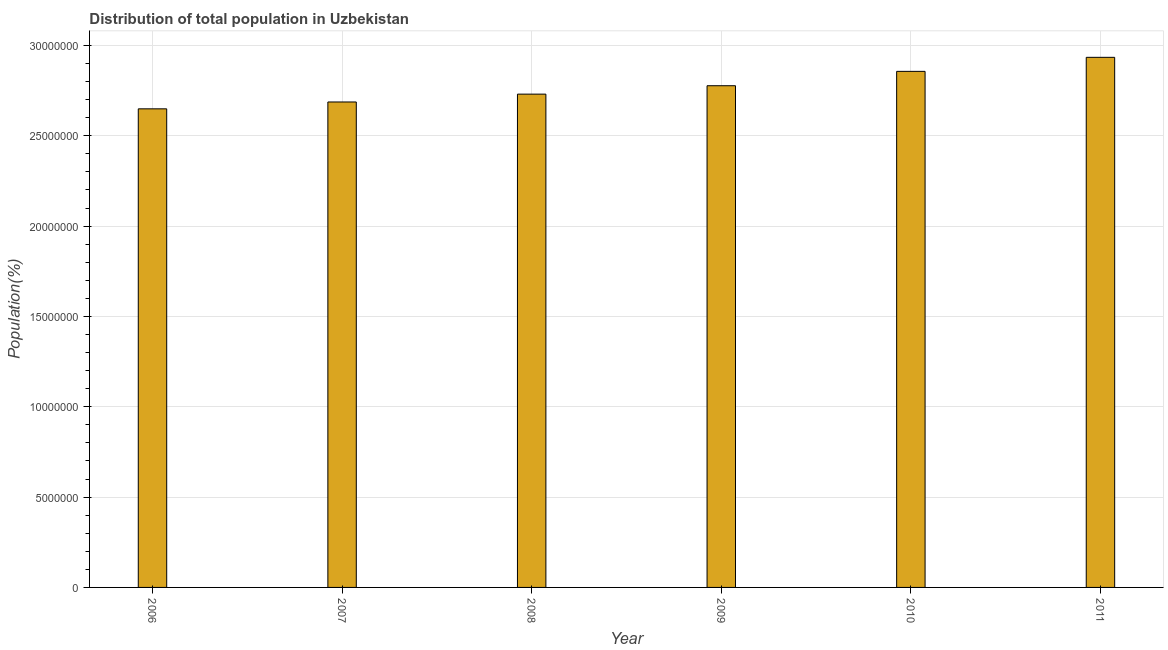Does the graph contain any zero values?
Your response must be concise. No. Does the graph contain grids?
Provide a short and direct response. Yes. What is the title of the graph?
Ensure brevity in your answer.  Distribution of total population in Uzbekistan . What is the label or title of the Y-axis?
Your response must be concise. Population(%). What is the population in 2006?
Your answer should be compact. 2.65e+07. Across all years, what is the maximum population?
Your answer should be very brief. 2.93e+07. Across all years, what is the minimum population?
Keep it short and to the point. 2.65e+07. In which year was the population minimum?
Your answer should be very brief. 2006. What is the sum of the population?
Provide a succinct answer. 1.66e+08. What is the difference between the population in 2007 and 2009?
Provide a succinct answer. -8.99e+05. What is the average population per year?
Your answer should be very brief. 2.77e+07. What is the median population?
Make the answer very short. 2.75e+07. What is the ratio of the population in 2006 to that in 2009?
Provide a short and direct response. 0.95. Is the population in 2006 less than that in 2007?
Offer a very short reply. Yes. Is the difference between the population in 2007 and 2008 greater than the difference between any two years?
Offer a terse response. No. What is the difference between the highest and the second highest population?
Your response must be concise. 7.77e+05. Is the sum of the population in 2010 and 2011 greater than the maximum population across all years?
Offer a terse response. Yes. What is the difference between the highest and the lowest population?
Your response must be concise. 2.85e+06. In how many years, is the population greater than the average population taken over all years?
Your answer should be compact. 3. How many bars are there?
Offer a terse response. 6. How many years are there in the graph?
Ensure brevity in your answer.  6. Are the values on the major ticks of Y-axis written in scientific E-notation?
Provide a succinct answer. No. What is the Population(%) of 2006?
Give a very brief answer. 2.65e+07. What is the Population(%) in 2007?
Your answer should be very brief. 2.69e+07. What is the Population(%) of 2008?
Your answer should be very brief. 2.73e+07. What is the Population(%) of 2009?
Ensure brevity in your answer.  2.78e+07. What is the Population(%) of 2010?
Provide a succinct answer. 2.86e+07. What is the Population(%) of 2011?
Offer a very short reply. 2.93e+07. What is the difference between the Population(%) in 2006 and 2007?
Your answer should be very brief. -3.80e+05. What is the difference between the Population(%) in 2006 and 2008?
Your response must be concise. -8.15e+05. What is the difference between the Population(%) in 2006 and 2009?
Provide a short and direct response. -1.28e+06. What is the difference between the Population(%) in 2006 and 2010?
Your response must be concise. -2.07e+06. What is the difference between the Population(%) in 2006 and 2011?
Give a very brief answer. -2.85e+06. What is the difference between the Population(%) in 2007 and 2008?
Offer a terse response. -4.35e+05. What is the difference between the Population(%) in 2007 and 2009?
Offer a terse response. -8.99e+05. What is the difference between the Population(%) in 2007 and 2010?
Offer a terse response. -1.69e+06. What is the difference between the Population(%) in 2007 and 2011?
Make the answer very short. -2.47e+06. What is the difference between the Population(%) in 2008 and 2009?
Make the answer very short. -4.65e+05. What is the difference between the Population(%) in 2008 and 2010?
Make the answer very short. -1.26e+06. What is the difference between the Population(%) in 2008 and 2011?
Give a very brief answer. -2.04e+06. What is the difference between the Population(%) in 2009 and 2010?
Provide a short and direct response. -7.95e+05. What is the difference between the Population(%) in 2009 and 2011?
Your response must be concise. -1.57e+06. What is the difference between the Population(%) in 2010 and 2011?
Offer a terse response. -7.77e+05. What is the ratio of the Population(%) in 2006 to that in 2008?
Offer a terse response. 0.97. What is the ratio of the Population(%) in 2006 to that in 2009?
Your answer should be very brief. 0.95. What is the ratio of the Population(%) in 2006 to that in 2010?
Offer a terse response. 0.93. What is the ratio of the Population(%) in 2006 to that in 2011?
Ensure brevity in your answer.  0.9. What is the ratio of the Population(%) in 2007 to that in 2009?
Your response must be concise. 0.97. What is the ratio of the Population(%) in 2007 to that in 2010?
Offer a terse response. 0.94. What is the ratio of the Population(%) in 2007 to that in 2011?
Make the answer very short. 0.92. What is the ratio of the Population(%) in 2008 to that in 2009?
Give a very brief answer. 0.98. What is the ratio of the Population(%) in 2008 to that in 2010?
Your answer should be very brief. 0.96. What is the ratio of the Population(%) in 2009 to that in 2011?
Your answer should be compact. 0.95. 